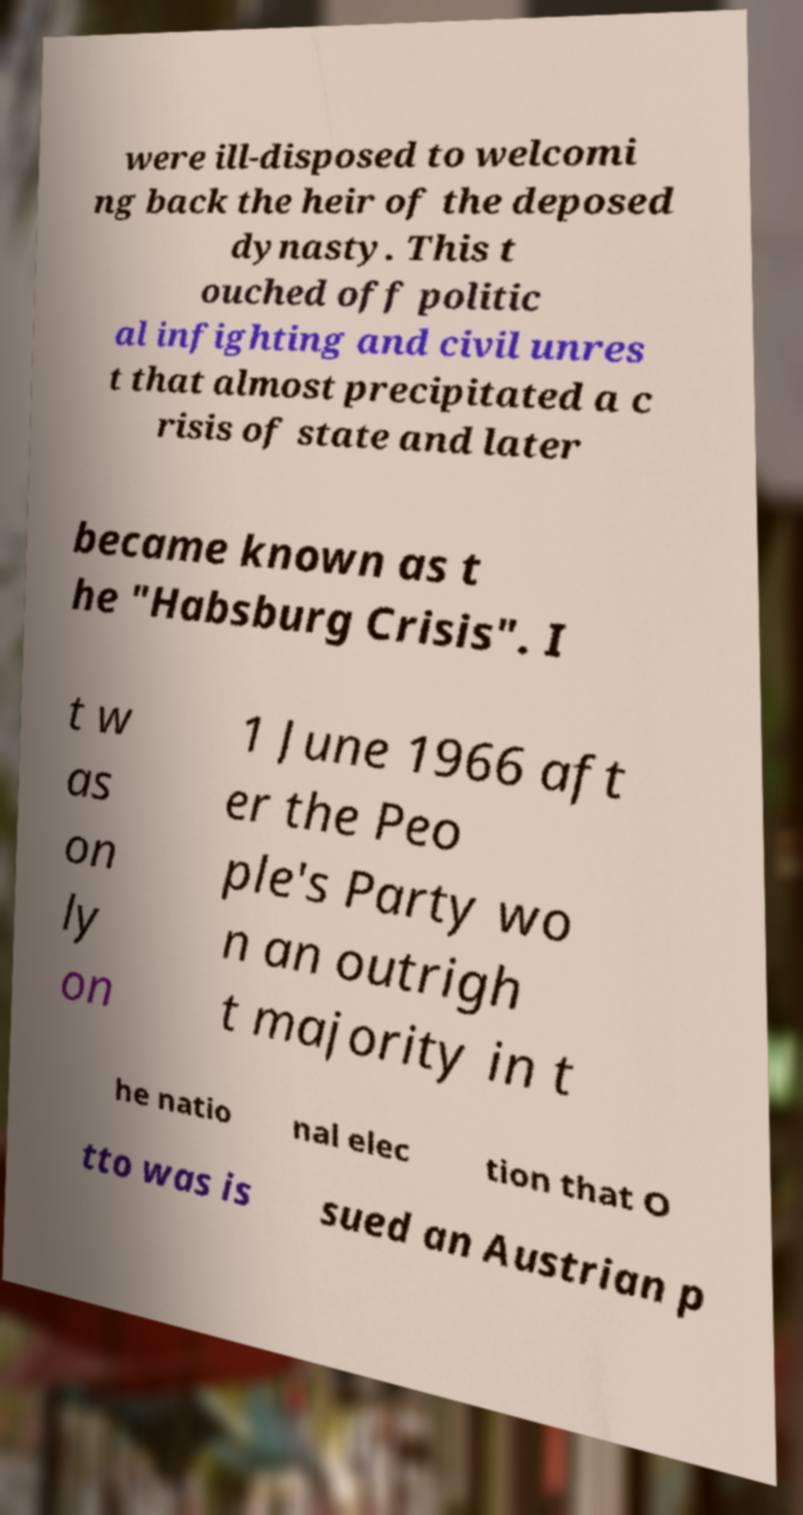Could you extract and type out the text from this image? were ill-disposed to welcomi ng back the heir of the deposed dynasty. This t ouched off politic al infighting and civil unres t that almost precipitated a c risis of state and later became known as t he "Habsburg Crisis". I t w as on ly on 1 June 1966 aft er the Peo ple's Party wo n an outrigh t majority in t he natio nal elec tion that O tto was is sued an Austrian p 